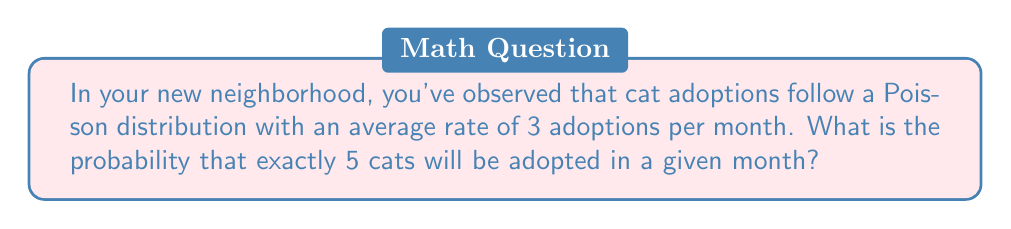Help me with this question. To solve this problem, we'll use the Poisson distribution formula:

$$P(X = k) = \frac{e^{-\lambda} \lambda^k}{k!}$$

Where:
$\lambda$ is the average rate of occurrences (in this case, 3 adoptions per month)
$k$ is the number of occurrences we're interested in (in this case, 5 adoptions)
$e$ is Euler's number (approximately 2.71828)

Let's plug in our values:

$\lambda = 3$
$k = 5$

$$P(X = 5) = \frac{e^{-3} 3^5}{5!}$$

Now, let's calculate step by step:

1) First, calculate $e^{-3}$:
   $e^{-3} \approx 0.0497871$

2) Calculate $3^5$:
   $3^5 = 243$

3) Calculate $5!$:
   $5! = 5 \times 4 \times 3 \times 2 \times 1 = 120$

4) Now, put it all together:
   $$P(X = 5) = \frac{0.0497871 \times 243}{120}$$

5) Simplify:
   $$P(X = 5) \approx 0.1008$$

Therefore, the probability of exactly 5 cats being adopted in a given month is approximately 0.1008 or 10.08%.
Answer: 0.1008 (or 10.08%) 